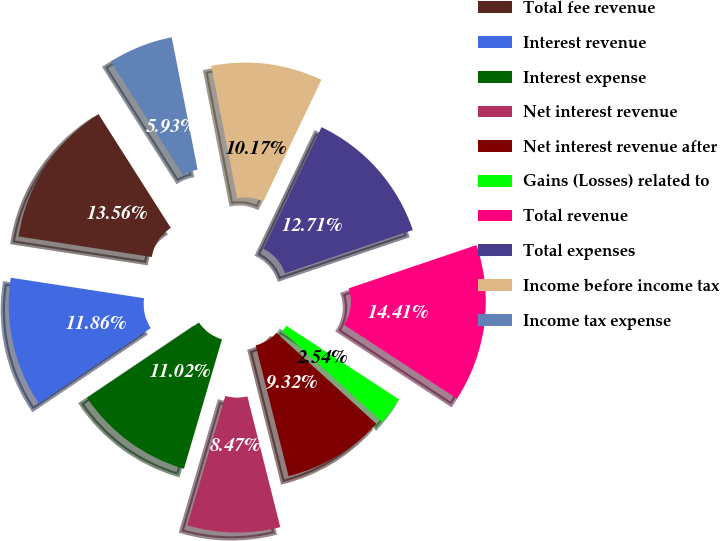<chart> <loc_0><loc_0><loc_500><loc_500><pie_chart><fcel>Total fee revenue<fcel>Interest revenue<fcel>Interest expense<fcel>Net interest revenue<fcel>Net interest revenue after<fcel>Gains (Losses) related to<fcel>Total revenue<fcel>Total expenses<fcel>Income before income tax<fcel>Income tax expense<nl><fcel>13.56%<fcel>11.86%<fcel>11.02%<fcel>8.47%<fcel>9.32%<fcel>2.54%<fcel>14.41%<fcel>12.71%<fcel>10.17%<fcel>5.93%<nl></chart> 